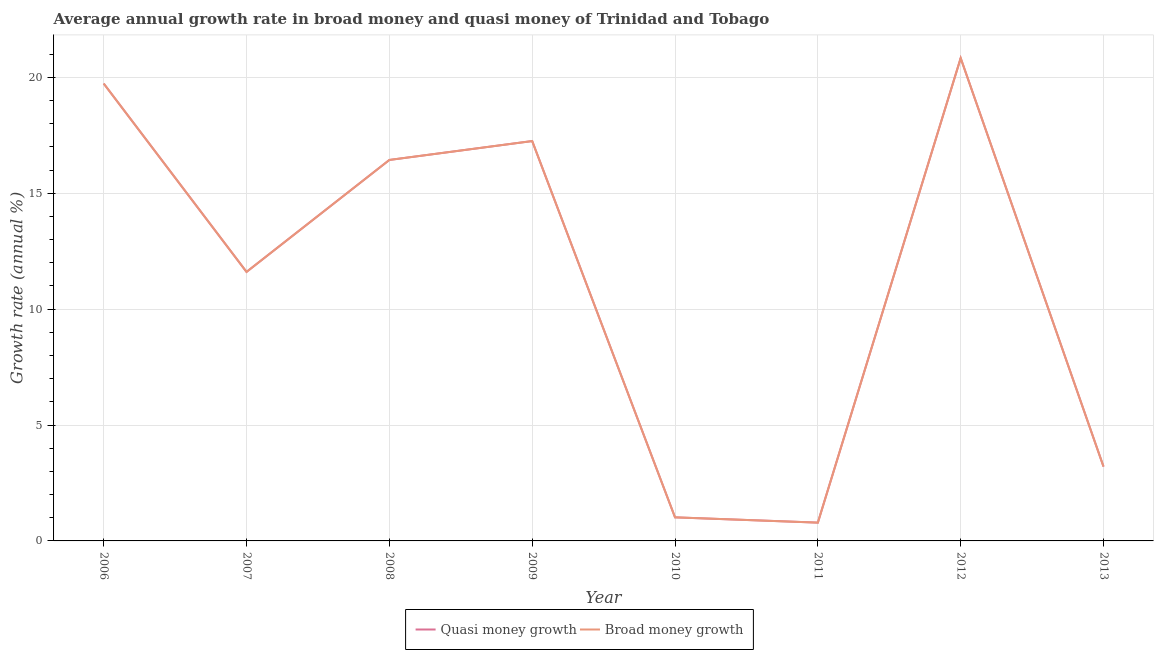Is the number of lines equal to the number of legend labels?
Provide a succinct answer. Yes. What is the annual growth rate in broad money in 2007?
Your answer should be compact. 11.61. Across all years, what is the maximum annual growth rate in quasi money?
Ensure brevity in your answer.  20.83. Across all years, what is the minimum annual growth rate in broad money?
Offer a terse response. 0.79. In which year was the annual growth rate in broad money minimum?
Offer a terse response. 2011. What is the total annual growth rate in quasi money in the graph?
Keep it short and to the point. 90.88. What is the difference between the annual growth rate in broad money in 2010 and that in 2012?
Ensure brevity in your answer.  -19.82. What is the difference between the annual growth rate in broad money in 2012 and the annual growth rate in quasi money in 2006?
Offer a terse response. 1.1. What is the average annual growth rate in quasi money per year?
Provide a succinct answer. 11.36. What is the ratio of the annual growth rate in broad money in 2011 to that in 2012?
Make the answer very short. 0.04. Is the annual growth rate in quasi money in 2006 less than that in 2011?
Keep it short and to the point. No. Is the difference between the annual growth rate in broad money in 2008 and 2009 greater than the difference between the annual growth rate in quasi money in 2008 and 2009?
Provide a short and direct response. No. What is the difference between the highest and the second highest annual growth rate in broad money?
Ensure brevity in your answer.  1.1. What is the difference between the highest and the lowest annual growth rate in quasi money?
Your answer should be very brief. 20.04. Is the sum of the annual growth rate in quasi money in 2006 and 2012 greater than the maximum annual growth rate in broad money across all years?
Provide a succinct answer. Yes. Is the annual growth rate in quasi money strictly less than the annual growth rate in broad money over the years?
Your answer should be very brief. No. How many lines are there?
Make the answer very short. 2. Are the values on the major ticks of Y-axis written in scientific E-notation?
Offer a terse response. No. Does the graph contain any zero values?
Your response must be concise. No. Does the graph contain grids?
Your answer should be very brief. Yes. Where does the legend appear in the graph?
Give a very brief answer. Bottom center. How many legend labels are there?
Provide a succinct answer. 2. What is the title of the graph?
Your response must be concise. Average annual growth rate in broad money and quasi money of Trinidad and Tobago. What is the label or title of the X-axis?
Your answer should be compact. Year. What is the label or title of the Y-axis?
Your answer should be very brief. Growth rate (annual %). What is the Growth rate (annual %) in Quasi money growth in 2006?
Offer a very short reply. 19.73. What is the Growth rate (annual %) of Broad money growth in 2006?
Provide a succinct answer. 19.73. What is the Growth rate (annual %) of Quasi money growth in 2007?
Provide a succinct answer. 11.61. What is the Growth rate (annual %) of Broad money growth in 2007?
Your answer should be compact. 11.61. What is the Growth rate (annual %) of Quasi money growth in 2008?
Provide a succinct answer. 16.44. What is the Growth rate (annual %) in Broad money growth in 2008?
Your answer should be compact. 16.44. What is the Growth rate (annual %) of Quasi money growth in 2009?
Give a very brief answer. 17.25. What is the Growth rate (annual %) in Broad money growth in 2009?
Your answer should be compact. 17.25. What is the Growth rate (annual %) of Quasi money growth in 2010?
Make the answer very short. 1.02. What is the Growth rate (annual %) in Broad money growth in 2010?
Your answer should be compact. 1.02. What is the Growth rate (annual %) in Quasi money growth in 2011?
Your answer should be very brief. 0.79. What is the Growth rate (annual %) in Broad money growth in 2011?
Offer a terse response. 0.79. What is the Growth rate (annual %) of Quasi money growth in 2012?
Make the answer very short. 20.83. What is the Growth rate (annual %) of Broad money growth in 2012?
Your answer should be very brief. 20.83. What is the Growth rate (annual %) in Quasi money growth in 2013?
Provide a succinct answer. 3.21. What is the Growth rate (annual %) of Broad money growth in 2013?
Provide a succinct answer. 3.21. Across all years, what is the maximum Growth rate (annual %) of Quasi money growth?
Your answer should be very brief. 20.83. Across all years, what is the maximum Growth rate (annual %) in Broad money growth?
Keep it short and to the point. 20.83. Across all years, what is the minimum Growth rate (annual %) of Quasi money growth?
Your response must be concise. 0.79. Across all years, what is the minimum Growth rate (annual %) in Broad money growth?
Offer a terse response. 0.79. What is the total Growth rate (annual %) of Quasi money growth in the graph?
Ensure brevity in your answer.  90.88. What is the total Growth rate (annual %) in Broad money growth in the graph?
Make the answer very short. 90.88. What is the difference between the Growth rate (annual %) in Quasi money growth in 2006 and that in 2007?
Your answer should be very brief. 8.13. What is the difference between the Growth rate (annual %) in Broad money growth in 2006 and that in 2007?
Provide a short and direct response. 8.13. What is the difference between the Growth rate (annual %) in Quasi money growth in 2006 and that in 2008?
Provide a succinct answer. 3.3. What is the difference between the Growth rate (annual %) of Broad money growth in 2006 and that in 2008?
Provide a short and direct response. 3.3. What is the difference between the Growth rate (annual %) in Quasi money growth in 2006 and that in 2009?
Ensure brevity in your answer.  2.48. What is the difference between the Growth rate (annual %) of Broad money growth in 2006 and that in 2009?
Give a very brief answer. 2.48. What is the difference between the Growth rate (annual %) of Quasi money growth in 2006 and that in 2010?
Ensure brevity in your answer.  18.72. What is the difference between the Growth rate (annual %) of Broad money growth in 2006 and that in 2010?
Your answer should be compact. 18.72. What is the difference between the Growth rate (annual %) of Quasi money growth in 2006 and that in 2011?
Offer a terse response. 18.94. What is the difference between the Growth rate (annual %) in Broad money growth in 2006 and that in 2011?
Your answer should be very brief. 18.94. What is the difference between the Growth rate (annual %) of Quasi money growth in 2006 and that in 2012?
Keep it short and to the point. -1.1. What is the difference between the Growth rate (annual %) of Broad money growth in 2006 and that in 2012?
Keep it short and to the point. -1.1. What is the difference between the Growth rate (annual %) in Quasi money growth in 2006 and that in 2013?
Your answer should be very brief. 16.53. What is the difference between the Growth rate (annual %) of Broad money growth in 2006 and that in 2013?
Provide a short and direct response. 16.53. What is the difference between the Growth rate (annual %) of Quasi money growth in 2007 and that in 2008?
Your answer should be very brief. -4.83. What is the difference between the Growth rate (annual %) in Broad money growth in 2007 and that in 2008?
Ensure brevity in your answer.  -4.83. What is the difference between the Growth rate (annual %) of Quasi money growth in 2007 and that in 2009?
Give a very brief answer. -5.65. What is the difference between the Growth rate (annual %) in Broad money growth in 2007 and that in 2009?
Provide a succinct answer. -5.65. What is the difference between the Growth rate (annual %) of Quasi money growth in 2007 and that in 2010?
Your response must be concise. 10.59. What is the difference between the Growth rate (annual %) of Broad money growth in 2007 and that in 2010?
Keep it short and to the point. 10.59. What is the difference between the Growth rate (annual %) of Quasi money growth in 2007 and that in 2011?
Your response must be concise. 10.82. What is the difference between the Growth rate (annual %) in Broad money growth in 2007 and that in 2011?
Ensure brevity in your answer.  10.82. What is the difference between the Growth rate (annual %) in Quasi money growth in 2007 and that in 2012?
Give a very brief answer. -9.22. What is the difference between the Growth rate (annual %) in Broad money growth in 2007 and that in 2012?
Provide a short and direct response. -9.22. What is the difference between the Growth rate (annual %) in Quasi money growth in 2007 and that in 2013?
Offer a terse response. 8.4. What is the difference between the Growth rate (annual %) of Broad money growth in 2007 and that in 2013?
Your answer should be very brief. 8.4. What is the difference between the Growth rate (annual %) of Quasi money growth in 2008 and that in 2009?
Provide a short and direct response. -0.82. What is the difference between the Growth rate (annual %) in Broad money growth in 2008 and that in 2009?
Offer a terse response. -0.82. What is the difference between the Growth rate (annual %) of Quasi money growth in 2008 and that in 2010?
Your answer should be very brief. 15.42. What is the difference between the Growth rate (annual %) of Broad money growth in 2008 and that in 2010?
Keep it short and to the point. 15.42. What is the difference between the Growth rate (annual %) in Quasi money growth in 2008 and that in 2011?
Offer a very short reply. 15.65. What is the difference between the Growth rate (annual %) of Broad money growth in 2008 and that in 2011?
Offer a very short reply. 15.65. What is the difference between the Growth rate (annual %) in Quasi money growth in 2008 and that in 2012?
Your response must be concise. -4.39. What is the difference between the Growth rate (annual %) of Broad money growth in 2008 and that in 2012?
Your answer should be compact. -4.39. What is the difference between the Growth rate (annual %) of Quasi money growth in 2008 and that in 2013?
Give a very brief answer. 13.23. What is the difference between the Growth rate (annual %) of Broad money growth in 2008 and that in 2013?
Provide a succinct answer. 13.23. What is the difference between the Growth rate (annual %) of Quasi money growth in 2009 and that in 2010?
Offer a terse response. 16.24. What is the difference between the Growth rate (annual %) in Broad money growth in 2009 and that in 2010?
Your response must be concise. 16.24. What is the difference between the Growth rate (annual %) in Quasi money growth in 2009 and that in 2011?
Your response must be concise. 16.46. What is the difference between the Growth rate (annual %) of Broad money growth in 2009 and that in 2011?
Ensure brevity in your answer.  16.46. What is the difference between the Growth rate (annual %) of Quasi money growth in 2009 and that in 2012?
Give a very brief answer. -3.58. What is the difference between the Growth rate (annual %) of Broad money growth in 2009 and that in 2012?
Your answer should be very brief. -3.58. What is the difference between the Growth rate (annual %) of Quasi money growth in 2009 and that in 2013?
Give a very brief answer. 14.05. What is the difference between the Growth rate (annual %) in Broad money growth in 2009 and that in 2013?
Your answer should be compact. 14.05. What is the difference between the Growth rate (annual %) of Quasi money growth in 2010 and that in 2011?
Provide a succinct answer. 0.23. What is the difference between the Growth rate (annual %) of Broad money growth in 2010 and that in 2011?
Keep it short and to the point. 0.23. What is the difference between the Growth rate (annual %) of Quasi money growth in 2010 and that in 2012?
Provide a succinct answer. -19.82. What is the difference between the Growth rate (annual %) of Broad money growth in 2010 and that in 2012?
Make the answer very short. -19.82. What is the difference between the Growth rate (annual %) of Quasi money growth in 2010 and that in 2013?
Keep it short and to the point. -2.19. What is the difference between the Growth rate (annual %) of Broad money growth in 2010 and that in 2013?
Provide a short and direct response. -2.19. What is the difference between the Growth rate (annual %) in Quasi money growth in 2011 and that in 2012?
Your response must be concise. -20.04. What is the difference between the Growth rate (annual %) in Broad money growth in 2011 and that in 2012?
Offer a very short reply. -20.04. What is the difference between the Growth rate (annual %) of Quasi money growth in 2011 and that in 2013?
Provide a succinct answer. -2.42. What is the difference between the Growth rate (annual %) in Broad money growth in 2011 and that in 2013?
Give a very brief answer. -2.42. What is the difference between the Growth rate (annual %) of Quasi money growth in 2012 and that in 2013?
Keep it short and to the point. 17.62. What is the difference between the Growth rate (annual %) of Broad money growth in 2012 and that in 2013?
Ensure brevity in your answer.  17.62. What is the difference between the Growth rate (annual %) of Quasi money growth in 2006 and the Growth rate (annual %) of Broad money growth in 2007?
Provide a succinct answer. 8.13. What is the difference between the Growth rate (annual %) in Quasi money growth in 2006 and the Growth rate (annual %) in Broad money growth in 2008?
Make the answer very short. 3.3. What is the difference between the Growth rate (annual %) of Quasi money growth in 2006 and the Growth rate (annual %) of Broad money growth in 2009?
Your answer should be very brief. 2.48. What is the difference between the Growth rate (annual %) of Quasi money growth in 2006 and the Growth rate (annual %) of Broad money growth in 2010?
Your response must be concise. 18.72. What is the difference between the Growth rate (annual %) of Quasi money growth in 2006 and the Growth rate (annual %) of Broad money growth in 2011?
Your answer should be compact. 18.94. What is the difference between the Growth rate (annual %) in Quasi money growth in 2006 and the Growth rate (annual %) in Broad money growth in 2012?
Offer a terse response. -1.1. What is the difference between the Growth rate (annual %) in Quasi money growth in 2006 and the Growth rate (annual %) in Broad money growth in 2013?
Ensure brevity in your answer.  16.53. What is the difference between the Growth rate (annual %) in Quasi money growth in 2007 and the Growth rate (annual %) in Broad money growth in 2008?
Keep it short and to the point. -4.83. What is the difference between the Growth rate (annual %) of Quasi money growth in 2007 and the Growth rate (annual %) of Broad money growth in 2009?
Offer a terse response. -5.65. What is the difference between the Growth rate (annual %) in Quasi money growth in 2007 and the Growth rate (annual %) in Broad money growth in 2010?
Give a very brief answer. 10.59. What is the difference between the Growth rate (annual %) of Quasi money growth in 2007 and the Growth rate (annual %) of Broad money growth in 2011?
Provide a succinct answer. 10.82. What is the difference between the Growth rate (annual %) in Quasi money growth in 2007 and the Growth rate (annual %) in Broad money growth in 2012?
Offer a terse response. -9.22. What is the difference between the Growth rate (annual %) of Quasi money growth in 2008 and the Growth rate (annual %) of Broad money growth in 2009?
Provide a succinct answer. -0.82. What is the difference between the Growth rate (annual %) in Quasi money growth in 2008 and the Growth rate (annual %) in Broad money growth in 2010?
Your answer should be very brief. 15.42. What is the difference between the Growth rate (annual %) of Quasi money growth in 2008 and the Growth rate (annual %) of Broad money growth in 2011?
Keep it short and to the point. 15.65. What is the difference between the Growth rate (annual %) in Quasi money growth in 2008 and the Growth rate (annual %) in Broad money growth in 2012?
Keep it short and to the point. -4.39. What is the difference between the Growth rate (annual %) of Quasi money growth in 2008 and the Growth rate (annual %) of Broad money growth in 2013?
Your response must be concise. 13.23. What is the difference between the Growth rate (annual %) of Quasi money growth in 2009 and the Growth rate (annual %) of Broad money growth in 2010?
Offer a terse response. 16.24. What is the difference between the Growth rate (annual %) in Quasi money growth in 2009 and the Growth rate (annual %) in Broad money growth in 2011?
Your answer should be compact. 16.46. What is the difference between the Growth rate (annual %) in Quasi money growth in 2009 and the Growth rate (annual %) in Broad money growth in 2012?
Keep it short and to the point. -3.58. What is the difference between the Growth rate (annual %) in Quasi money growth in 2009 and the Growth rate (annual %) in Broad money growth in 2013?
Provide a succinct answer. 14.05. What is the difference between the Growth rate (annual %) in Quasi money growth in 2010 and the Growth rate (annual %) in Broad money growth in 2011?
Your answer should be compact. 0.23. What is the difference between the Growth rate (annual %) of Quasi money growth in 2010 and the Growth rate (annual %) of Broad money growth in 2012?
Provide a succinct answer. -19.82. What is the difference between the Growth rate (annual %) in Quasi money growth in 2010 and the Growth rate (annual %) in Broad money growth in 2013?
Ensure brevity in your answer.  -2.19. What is the difference between the Growth rate (annual %) in Quasi money growth in 2011 and the Growth rate (annual %) in Broad money growth in 2012?
Keep it short and to the point. -20.04. What is the difference between the Growth rate (annual %) in Quasi money growth in 2011 and the Growth rate (annual %) in Broad money growth in 2013?
Offer a terse response. -2.42. What is the difference between the Growth rate (annual %) of Quasi money growth in 2012 and the Growth rate (annual %) of Broad money growth in 2013?
Your answer should be compact. 17.62. What is the average Growth rate (annual %) of Quasi money growth per year?
Make the answer very short. 11.36. What is the average Growth rate (annual %) of Broad money growth per year?
Offer a terse response. 11.36. In the year 2006, what is the difference between the Growth rate (annual %) in Quasi money growth and Growth rate (annual %) in Broad money growth?
Ensure brevity in your answer.  0. In the year 2007, what is the difference between the Growth rate (annual %) of Quasi money growth and Growth rate (annual %) of Broad money growth?
Give a very brief answer. 0. In the year 2009, what is the difference between the Growth rate (annual %) in Quasi money growth and Growth rate (annual %) in Broad money growth?
Keep it short and to the point. 0. In the year 2010, what is the difference between the Growth rate (annual %) in Quasi money growth and Growth rate (annual %) in Broad money growth?
Your answer should be very brief. 0. In the year 2013, what is the difference between the Growth rate (annual %) of Quasi money growth and Growth rate (annual %) of Broad money growth?
Your answer should be very brief. 0. What is the ratio of the Growth rate (annual %) in Quasi money growth in 2006 to that in 2007?
Your answer should be compact. 1.7. What is the ratio of the Growth rate (annual %) of Broad money growth in 2006 to that in 2007?
Your answer should be very brief. 1.7. What is the ratio of the Growth rate (annual %) in Quasi money growth in 2006 to that in 2008?
Offer a terse response. 1.2. What is the ratio of the Growth rate (annual %) in Broad money growth in 2006 to that in 2008?
Give a very brief answer. 1.2. What is the ratio of the Growth rate (annual %) in Quasi money growth in 2006 to that in 2009?
Keep it short and to the point. 1.14. What is the ratio of the Growth rate (annual %) in Broad money growth in 2006 to that in 2009?
Keep it short and to the point. 1.14. What is the ratio of the Growth rate (annual %) in Quasi money growth in 2006 to that in 2010?
Give a very brief answer. 19.4. What is the ratio of the Growth rate (annual %) in Broad money growth in 2006 to that in 2010?
Provide a short and direct response. 19.4. What is the ratio of the Growth rate (annual %) of Quasi money growth in 2006 to that in 2011?
Your response must be concise. 25. What is the ratio of the Growth rate (annual %) of Broad money growth in 2006 to that in 2011?
Your answer should be very brief. 25. What is the ratio of the Growth rate (annual %) of Quasi money growth in 2006 to that in 2012?
Keep it short and to the point. 0.95. What is the ratio of the Growth rate (annual %) of Broad money growth in 2006 to that in 2012?
Your answer should be very brief. 0.95. What is the ratio of the Growth rate (annual %) of Quasi money growth in 2006 to that in 2013?
Provide a short and direct response. 6.15. What is the ratio of the Growth rate (annual %) of Broad money growth in 2006 to that in 2013?
Your response must be concise. 6.15. What is the ratio of the Growth rate (annual %) in Quasi money growth in 2007 to that in 2008?
Your answer should be very brief. 0.71. What is the ratio of the Growth rate (annual %) in Broad money growth in 2007 to that in 2008?
Make the answer very short. 0.71. What is the ratio of the Growth rate (annual %) of Quasi money growth in 2007 to that in 2009?
Offer a very short reply. 0.67. What is the ratio of the Growth rate (annual %) of Broad money growth in 2007 to that in 2009?
Keep it short and to the point. 0.67. What is the ratio of the Growth rate (annual %) of Quasi money growth in 2007 to that in 2010?
Offer a terse response. 11.41. What is the ratio of the Growth rate (annual %) of Broad money growth in 2007 to that in 2010?
Your answer should be compact. 11.41. What is the ratio of the Growth rate (annual %) of Quasi money growth in 2007 to that in 2011?
Make the answer very short. 14.7. What is the ratio of the Growth rate (annual %) of Broad money growth in 2007 to that in 2011?
Provide a short and direct response. 14.7. What is the ratio of the Growth rate (annual %) in Quasi money growth in 2007 to that in 2012?
Offer a very short reply. 0.56. What is the ratio of the Growth rate (annual %) in Broad money growth in 2007 to that in 2012?
Ensure brevity in your answer.  0.56. What is the ratio of the Growth rate (annual %) in Quasi money growth in 2007 to that in 2013?
Provide a succinct answer. 3.62. What is the ratio of the Growth rate (annual %) of Broad money growth in 2007 to that in 2013?
Your response must be concise. 3.62. What is the ratio of the Growth rate (annual %) in Quasi money growth in 2008 to that in 2009?
Give a very brief answer. 0.95. What is the ratio of the Growth rate (annual %) of Broad money growth in 2008 to that in 2009?
Your answer should be very brief. 0.95. What is the ratio of the Growth rate (annual %) in Quasi money growth in 2008 to that in 2010?
Your answer should be compact. 16.16. What is the ratio of the Growth rate (annual %) of Broad money growth in 2008 to that in 2010?
Your response must be concise. 16.16. What is the ratio of the Growth rate (annual %) in Quasi money growth in 2008 to that in 2011?
Provide a succinct answer. 20.82. What is the ratio of the Growth rate (annual %) in Broad money growth in 2008 to that in 2011?
Ensure brevity in your answer.  20.82. What is the ratio of the Growth rate (annual %) in Quasi money growth in 2008 to that in 2012?
Your answer should be very brief. 0.79. What is the ratio of the Growth rate (annual %) of Broad money growth in 2008 to that in 2012?
Give a very brief answer. 0.79. What is the ratio of the Growth rate (annual %) in Quasi money growth in 2008 to that in 2013?
Ensure brevity in your answer.  5.12. What is the ratio of the Growth rate (annual %) of Broad money growth in 2008 to that in 2013?
Ensure brevity in your answer.  5.12. What is the ratio of the Growth rate (annual %) in Quasi money growth in 2009 to that in 2010?
Ensure brevity in your answer.  16.96. What is the ratio of the Growth rate (annual %) in Broad money growth in 2009 to that in 2010?
Your response must be concise. 16.96. What is the ratio of the Growth rate (annual %) in Quasi money growth in 2009 to that in 2011?
Give a very brief answer. 21.86. What is the ratio of the Growth rate (annual %) of Broad money growth in 2009 to that in 2011?
Provide a short and direct response. 21.86. What is the ratio of the Growth rate (annual %) of Quasi money growth in 2009 to that in 2012?
Offer a very short reply. 0.83. What is the ratio of the Growth rate (annual %) in Broad money growth in 2009 to that in 2012?
Your response must be concise. 0.83. What is the ratio of the Growth rate (annual %) of Quasi money growth in 2009 to that in 2013?
Offer a very short reply. 5.38. What is the ratio of the Growth rate (annual %) in Broad money growth in 2009 to that in 2013?
Offer a very short reply. 5.38. What is the ratio of the Growth rate (annual %) of Quasi money growth in 2010 to that in 2011?
Offer a terse response. 1.29. What is the ratio of the Growth rate (annual %) of Broad money growth in 2010 to that in 2011?
Your answer should be very brief. 1.29. What is the ratio of the Growth rate (annual %) of Quasi money growth in 2010 to that in 2012?
Provide a short and direct response. 0.05. What is the ratio of the Growth rate (annual %) of Broad money growth in 2010 to that in 2012?
Keep it short and to the point. 0.05. What is the ratio of the Growth rate (annual %) in Quasi money growth in 2010 to that in 2013?
Provide a succinct answer. 0.32. What is the ratio of the Growth rate (annual %) of Broad money growth in 2010 to that in 2013?
Offer a terse response. 0.32. What is the ratio of the Growth rate (annual %) in Quasi money growth in 2011 to that in 2012?
Provide a short and direct response. 0.04. What is the ratio of the Growth rate (annual %) in Broad money growth in 2011 to that in 2012?
Offer a terse response. 0.04. What is the ratio of the Growth rate (annual %) in Quasi money growth in 2011 to that in 2013?
Offer a terse response. 0.25. What is the ratio of the Growth rate (annual %) of Broad money growth in 2011 to that in 2013?
Provide a succinct answer. 0.25. What is the ratio of the Growth rate (annual %) in Quasi money growth in 2012 to that in 2013?
Offer a terse response. 6.5. What is the ratio of the Growth rate (annual %) in Broad money growth in 2012 to that in 2013?
Provide a succinct answer. 6.5. What is the difference between the highest and the second highest Growth rate (annual %) of Quasi money growth?
Provide a succinct answer. 1.1. What is the difference between the highest and the second highest Growth rate (annual %) of Broad money growth?
Provide a short and direct response. 1.1. What is the difference between the highest and the lowest Growth rate (annual %) in Quasi money growth?
Your response must be concise. 20.04. What is the difference between the highest and the lowest Growth rate (annual %) in Broad money growth?
Your answer should be very brief. 20.04. 